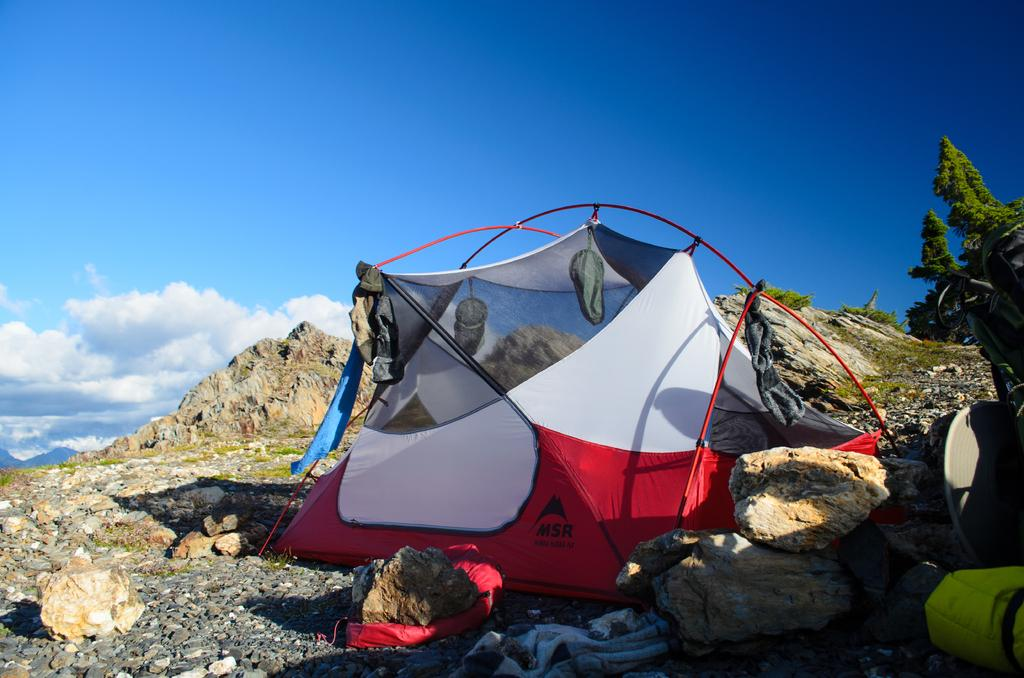What type of tent is shown in the image? There is a red and white color camping tent in the image. Where is the tent located? The tent is placed on the ground. What can be seen in the background of the image? Mountains, trees, and the sky are visible in the background of the image. What is the condition of the sky in the image? Clouds are present in the sky. What type of stocking is hanging from the tent in the image? There is no stocking hanging from the tent in the image. What type of destruction can be seen happening to the mountains in the image? There is no destruction visible in the image; the mountains appear to be intact. 